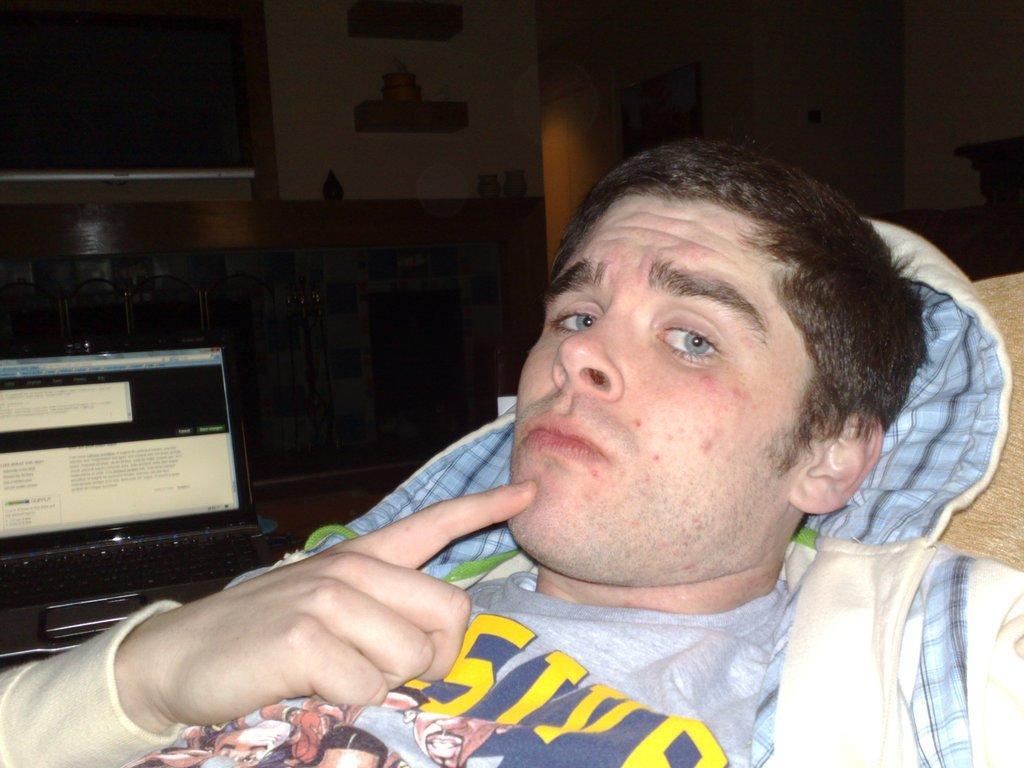Can you describe this image briefly? In the image there is a man lying. Beside him there is a laptop. Behind the laptop there is a wall with cupboards, television and some other things. In the background there is a wall with a frame. 